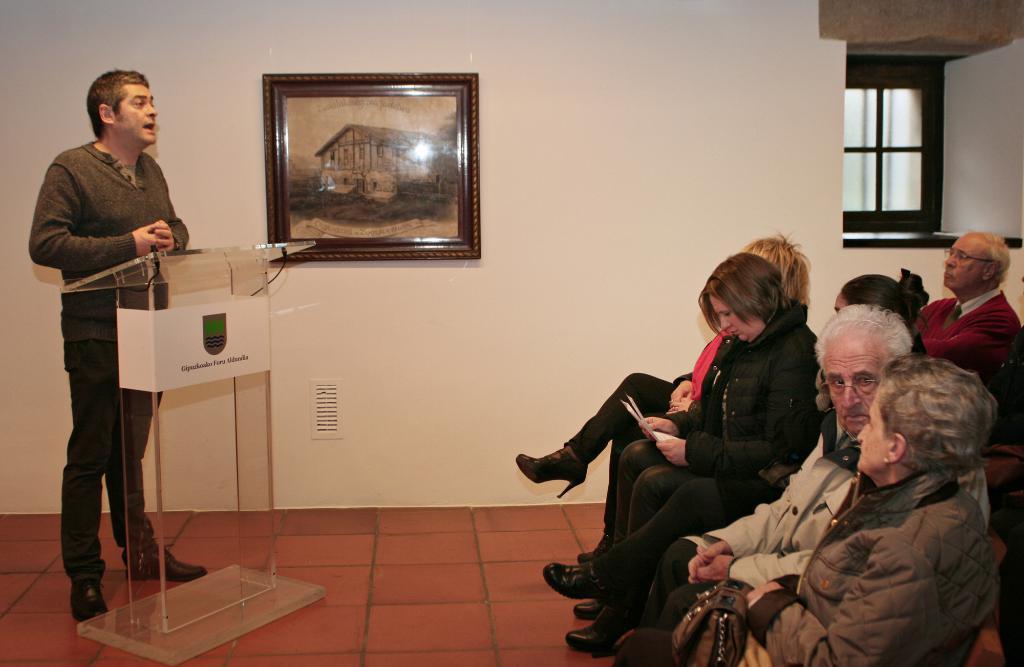How would you summarize this image in a sentence or two? In this image we can able to see some persons sitting over here, and there is a person standing and he is talking, in front of him there is a podium, and we can able to see a wall, on that wall we can able to see a frame which consists of a house picture on it, we can able to see a window, and there is a lady who is carrying a bag,and there is another lady who is holding some papers. 